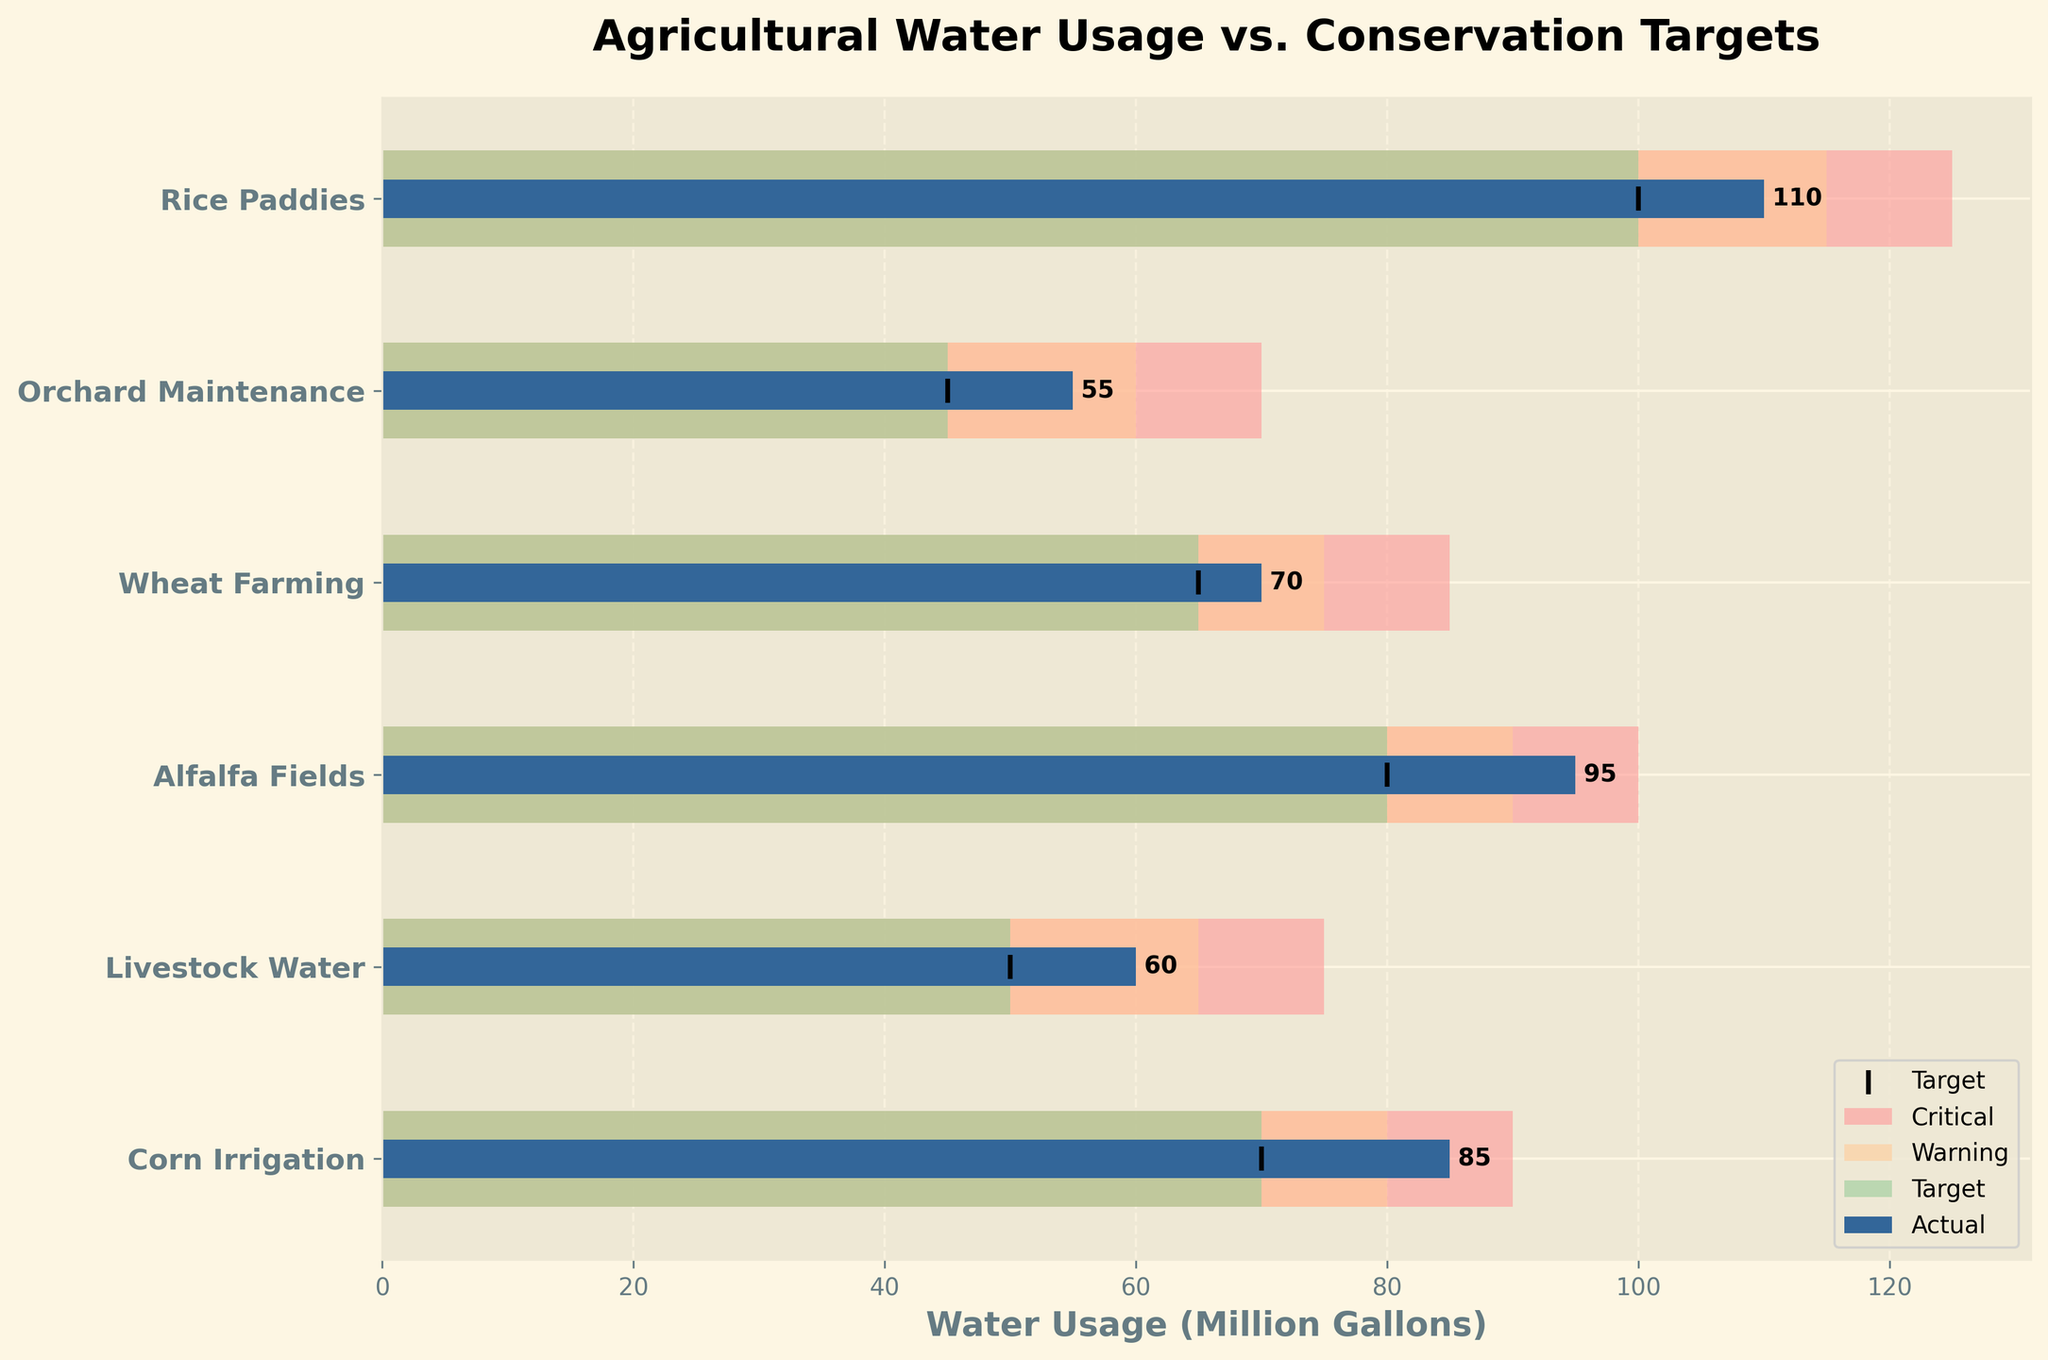What is the actual water usage for Livestock Water? Referring to the bar labeled 'Livestock Water', the actual usage is shown by a darker colored bar with a value label indicating the usage in million gallons. The label shows '60'.
Answer: 60 Which category exceeds its critical water usage level? By examining the length of the actual usage bars and comparing them to the critical level backgrounds, we can see that all categories, except for 'Rice Paddies', have actual usage bars shorter than their respective critical levels. 'Rice Paddies' bar exceeds the critical level of 125 million gallons.
Answer: Rice Paddies How many categories are listed in the chart? By counting the number of different bars along the vertical axis, we can see that there are 6 distinct categories.
Answer: 6 Which water usage exceeds the set target by the largest margin? To find this, subtract the target value from the actual value for each category. The largest difference will indicate the largest margin of excess. Corn Irrigation: 85-70=15, Livestock Water: 60-50=10, Alfalfa Fields: 95-80=15, Wheat Farming: 70-65=5, Orchard Maintenance: 55-45=10, Rice Paddies: 110-100=10. Both Corn Irrigation and Alfalfa Fields have the largest margin of 15.
Answer: Corn Irrigation, Alfalfa Fields What is the average actual water usage across all categories? Sum the actual usage values and divide by the number of categories. (85 + 60 + 95 + 70 + 55 + 110) / 6 = 475 / 6 ≈ 79.17
Answer: 79.17 By how many million gallons does Wheat Farming's water usage fall within the warning zone? Refer to the visual background for the warning zone, which ranges from 65 to 75. Calculate how much the Wheat Farming usage (70) falls within this range. Since 70 is within 65 and 75, it falls completely within the middle of the warning zone.
Answer: 5 Which categories are within their target water usage? Compare the length of the actual usage bars to the length of the target markers. Orchard Maintenance (55) is the only category that is within its target range of 45-60.
Answer: Orchard Maintenance What is the difference between the largest and smallest actual water usages? Identify the minimum (55 million gallons for Orchard Maintenance) and maximum (110 million gallons for Rice Paddies) actual water usage values. Subtract the smallest from the largest: 110 - 55 = 55.
Answer: 55 